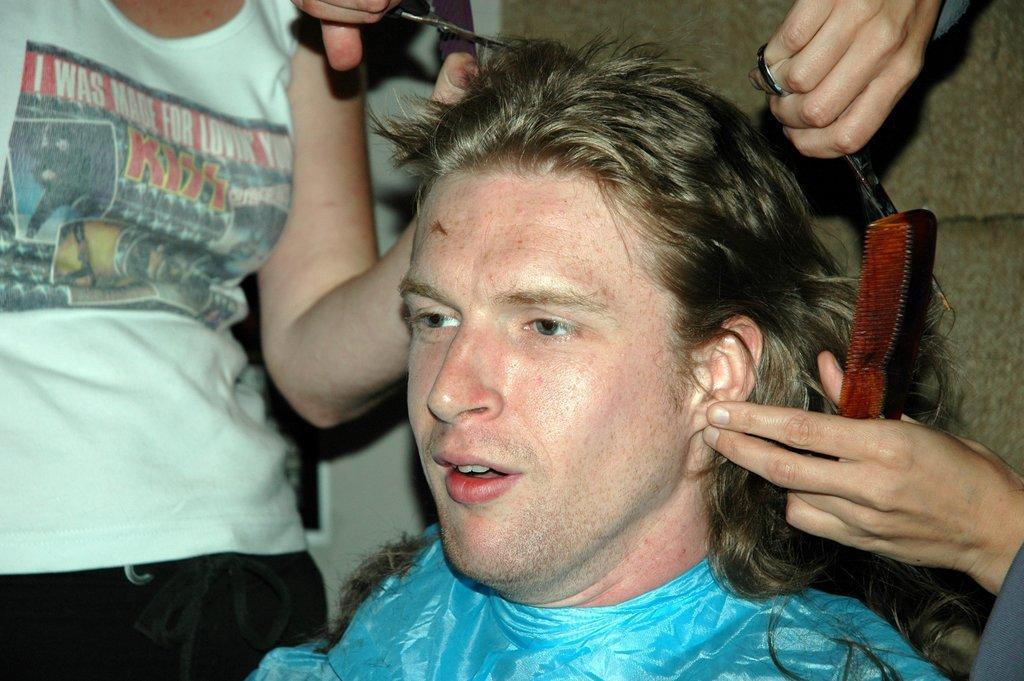What is the person in the image doing? There is a person sitting in the image. How many people are standing in the image? There are two people standing in the image. What are the two standing people holding? The two standing people are holding scissors. What impulse do the two standing people have in the image? There is no indication of any impulses or emotions in the image, as it only shows people holding scissors. 